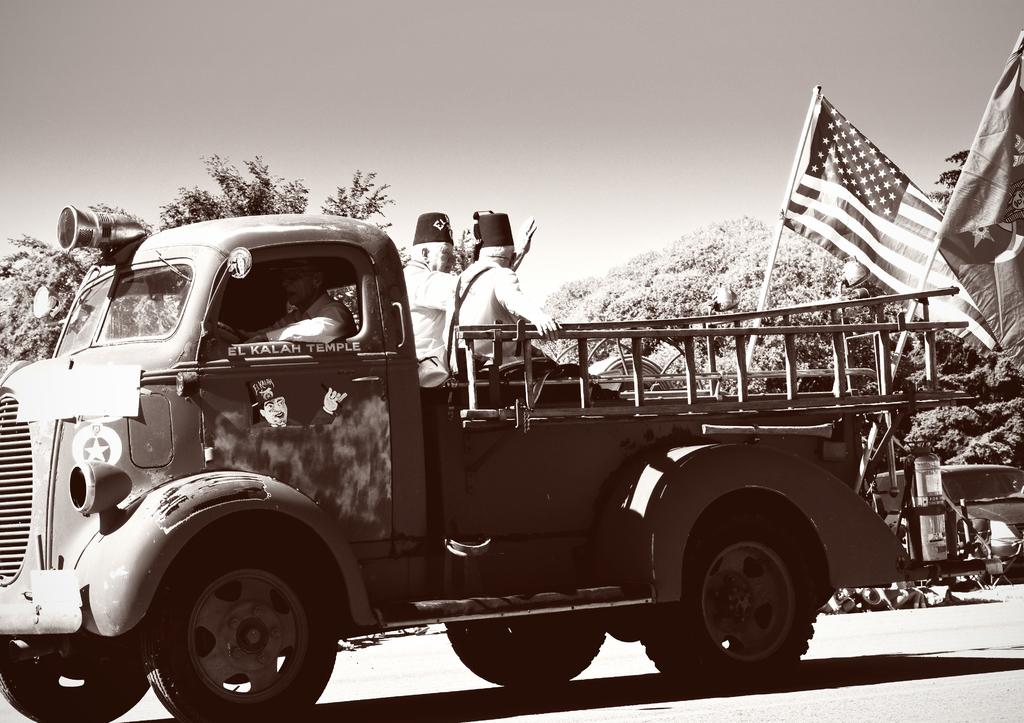What is the color scheme of the image? The image is black and white. What can be seen on the road in the image? There is a vehicle on the road in the image. Who or what can be seen in the image besides the vehicle? There are people visible in the image. What objects are present in the image that represent a country or organization? There are flags in the image. What type of natural vegetation is visible in the image? There are trees in the image. What is visible in the background of the image? The sky is visible in the background of the image. Can you see any wings on the people in the image? There are no wings visible on the people in the image. Is there any wound visible on the vehicle in the image? There is no wound visible on the vehicle in the image. 